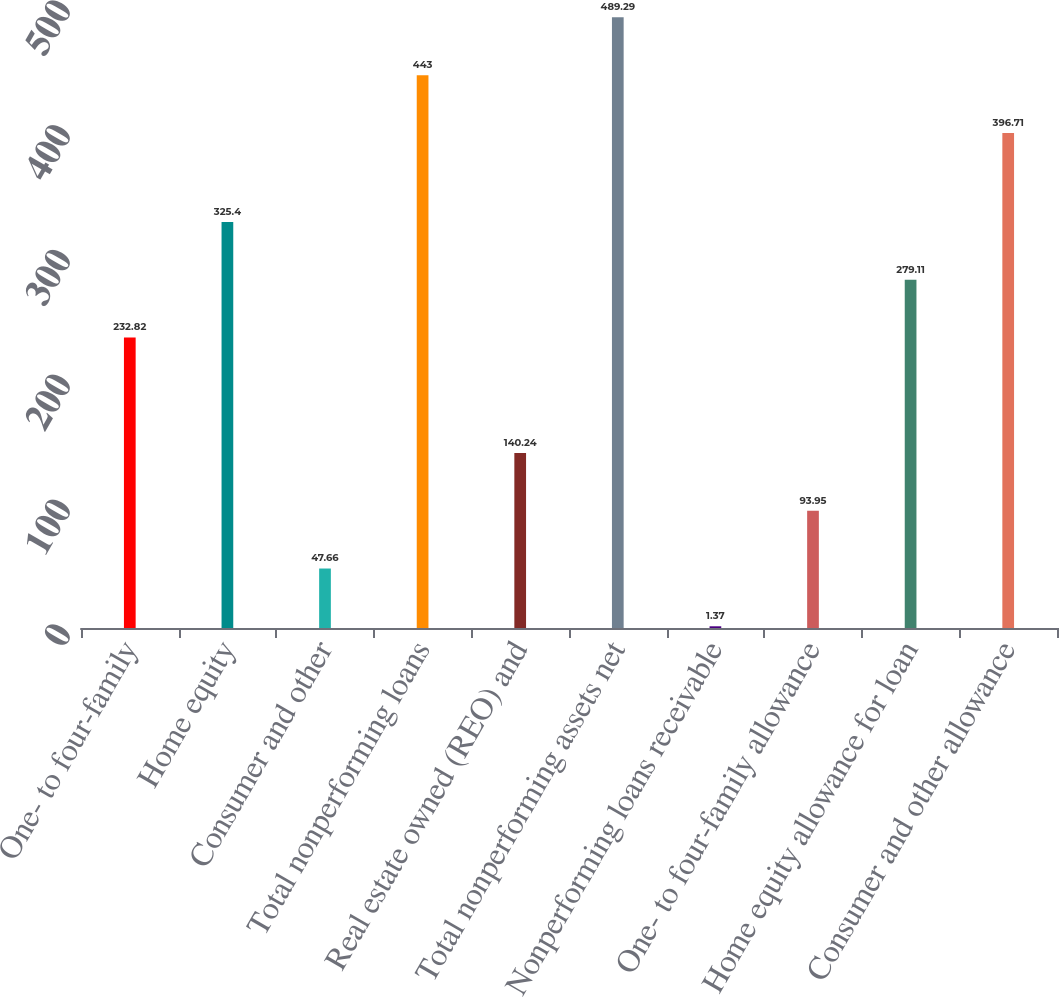<chart> <loc_0><loc_0><loc_500><loc_500><bar_chart><fcel>One- to four-family<fcel>Home equity<fcel>Consumer and other<fcel>Total nonperforming loans<fcel>Real estate owned (REO) and<fcel>Total nonperforming assets net<fcel>Nonperforming loans receivable<fcel>One- to four-family allowance<fcel>Home equity allowance for loan<fcel>Consumer and other allowance<nl><fcel>232.82<fcel>325.4<fcel>47.66<fcel>443<fcel>140.24<fcel>489.29<fcel>1.37<fcel>93.95<fcel>279.11<fcel>396.71<nl></chart> 